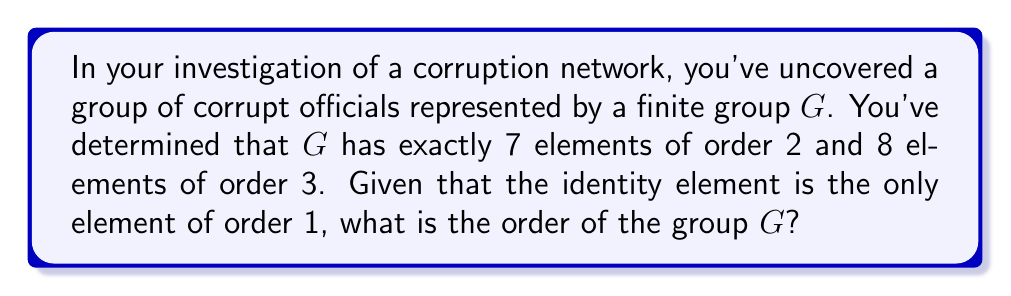Help me with this question. Let's approach this step-by-step:

1) First, recall that in a finite group, the order of the group must be divisible by the order of each of its elements (Lagrange's theorem).

2) We're given that there are:
   - 1 element of order 1 (the identity)
   - 7 elements of order 2
   - 8 elements of order 3

3) Let $|G|$ be the order of the group. From Lagrange's theorem, we know that:
   $$|G| \equiv 0 \pmod{2}$$ and $$|G| \equiv 0 \pmod{3}$$

4) This means that $|G|$ must be divisible by both 2 and 3. The least common multiple of 2 and 3 is 6, so:
   $$|G| \equiv 0 \pmod{6}$$

5) Now, let's count the total number of elements we know about:
   $$1 + 7 + 8 = 16$$

6) Since we've accounted for 16 elements, and $|G|$ must be divisible by 6, the smallest possible value for $|G|$ that satisfies both conditions is 18.

7) To verify, let's check if 18 is consistent with our data:
   - We've accounted for 16 elements.
   - The remaining 2 elements must be of order 6 (as 6 is the only divisor of 18 we haven't used yet).
   - This is consistent because elements of order 6 wouldn't have been counted in our initial data.

Therefore, the order of the group $G$ is 18.
Answer: The order of the group $G$ is 18. 